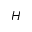<formula> <loc_0><loc_0><loc_500><loc_500>H</formula> 